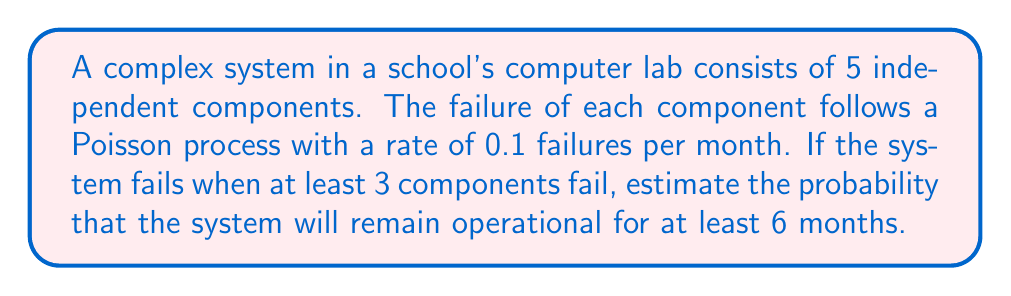Provide a solution to this math problem. Let's approach this step-by-step:

1) First, we need to understand that the system fails when 3 or more components fail. So, we need to find the probability that 0, 1, or 2 components fail within 6 months.

2) The number of failures for each component in 6 months follows a Poisson distribution with rate $\lambda = 0.1 \times 6 = 0.6$.

3) The probability of exactly $k$ failures in 6 months for a single component is given by the Poisson probability mass function:

   $$P(X=k) = \frac{e^{-\lambda}\lambda^k}{k!}$$

4) We need to calculate $P(X=0)$, $P(X=1)$, and $P(X=2)$ for a single component:

   $$P(X=0) = \frac{e^{-0.6}(0.6)^0}{0!} = e^{-0.6} \approx 0.5488$$
   $$P(X=1) = \frac{e^{-0.6}(0.6)^1}{1!} = 0.6e^{-0.6} \approx 0.3293$$
   $$P(X=2) = \frac{e^{-0.6}(0.6)^2}{2!} = 0.18e^{-0.6} \approx 0.0988$$

5) The probability that a single component doesn't fail 3 or more times is:

   $$P(X < 3) = P(X=0) + P(X=1) + P(X=2) \approx 0.5488 + 0.3293 + 0.0988 = 0.9769$$

6) For the entire system to remain operational, we need at least 3 out of 5 components to not fail 3 or more times. This follows a binomial distribution with $n=5$ and $p=0.9769$.

7) The probability is:

   $$P(\text{system operational}) = \sum_{k=3}^5 \binom{5}{k}(0.9769)^k(1-0.9769)^{5-k}$$

8) Calculating this:

   $$\binom{5}{3}(0.9769)^3(0.0231)^2 + \binom{5}{4}(0.9769)^4(0.0231)^1 + \binom{5}{5}(0.9769)^5(0.0231)^0$$
   $$= 10 \times 0.9315 \times 0.0005 + 5 \times 0.9545 \times 0.0231 + 1 \times 0.9769 \times 1$$
   $$= 0.0047 + 0.1102 + 0.9769 = 0.9918$$

Therefore, the probability that the system will remain operational for at least 6 months is approximately 0.9918 or 99.18%.
Answer: 0.9918 